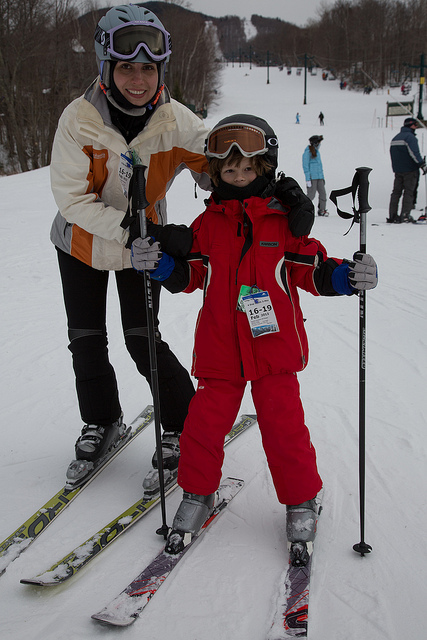Read all the text in this image. 16 19 